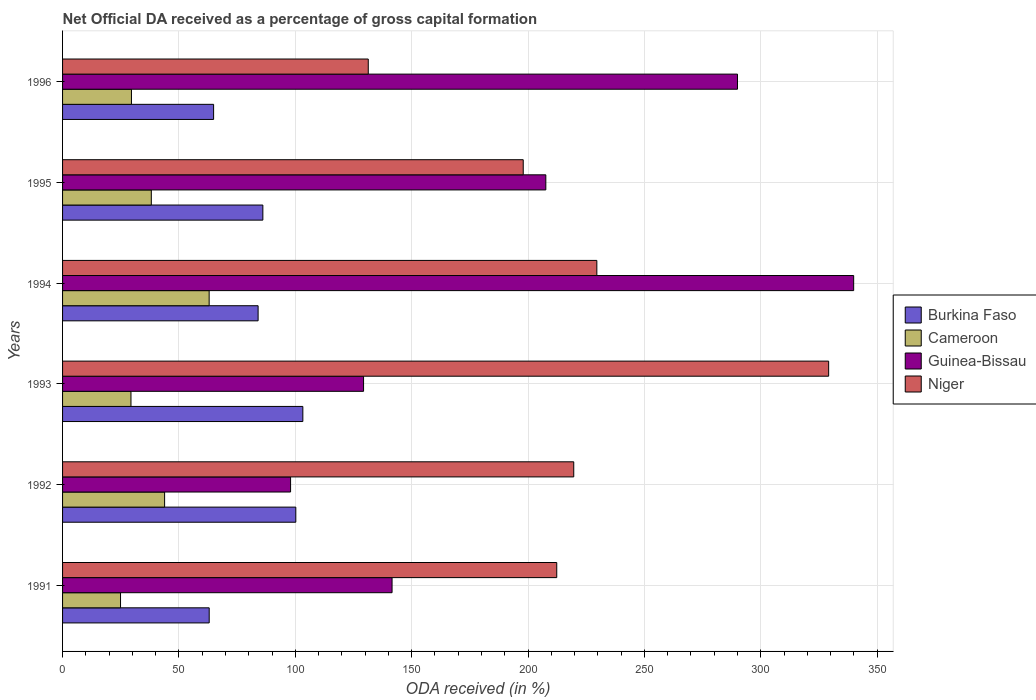How many different coloured bars are there?
Your answer should be compact. 4. How many groups of bars are there?
Ensure brevity in your answer.  6. Are the number of bars on each tick of the Y-axis equal?
Offer a terse response. Yes. How many bars are there on the 1st tick from the top?
Provide a short and direct response. 4. What is the label of the 1st group of bars from the top?
Offer a terse response. 1996. In how many cases, is the number of bars for a given year not equal to the number of legend labels?
Offer a very short reply. 0. What is the net ODA received in Niger in 1996?
Give a very brief answer. 131.35. Across all years, what is the maximum net ODA received in Niger?
Offer a very short reply. 329.16. Across all years, what is the minimum net ODA received in Guinea-Bissau?
Offer a terse response. 97.97. In which year was the net ODA received in Burkina Faso maximum?
Make the answer very short. 1993. What is the total net ODA received in Niger in the graph?
Provide a succinct answer. 1319.97. What is the difference between the net ODA received in Niger in 1993 and that in 1994?
Provide a short and direct response. 99.6. What is the difference between the net ODA received in Burkina Faso in 1991 and the net ODA received in Cameroon in 1995?
Make the answer very short. 24.87. What is the average net ODA received in Niger per year?
Your response must be concise. 220. In the year 1995, what is the difference between the net ODA received in Burkina Faso and net ODA received in Niger?
Provide a short and direct response. -111.87. In how many years, is the net ODA received in Guinea-Bissau greater than 130 %?
Provide a short and direct response. 4. What is the ratio of the net ODA received in Burkina Faso in 1992 to that in 1993?
Provide a short and direct response. 0.97. Is the net ODA received in Niger in 1993 less than that in 1996?
Provide a short and direct response. No. What is the difference between the highest and the second highest net ODA received in Cameroon?
Offer a terse response. 19.14. What is the difference between the highest and the lowest net ODA received in Guinea-Bissau?
Offer a very short reply. 241.94. In how many years, is the net ODA received in Niger greater than the average net ODA received in Niger taken over all years?
Provide a succinct answer. 2. What does the 4th bar from the top in 1996 represents?
Provide a succinct answer. Burkina Faso. What does the 4th bar from the bottom in 1992 represents?
Provide a succinct answer. Niger. How many bars are there?
Offer a very short reply. 24. Are all the bars in the graph horizontal?
Provide a short and direct response. Yes. How many years are there in the graph?
Give a very brief answer. 6. Does the graph contain any zero values?
Make the answer very short. No. Where does the legend appear in the graph?
Your response must be concise. Center right. How are the legend labels stacked?
Ensure brevity in your answer.  Vertical. What is the title of the graph?
Give a very brief answer. Net Official DA received as a percentage of gross capital formation. What is the label or title of the X-axis?
Your answer should be very brief. ODA received (in %). What is the label or title of the Y-axis?
Provide a succinct answer. Years. What is the ODA received (in %) in Burkina Faso in 1991?
Make the answer very short. 63. What is the ODA received (in %) of Cameroon in 1991?
Make the answer very short. 24.9. What is the ODA received (in %) of Guinea-Bissau in 1991?
Offer a very short reply. 141.57. What is the ODA received (in %) of Niger in 1991?
Offer a terse response. 212.33. What is the ODA received (in %) in Burkina Faso in 1992?
Provide a short and direct response. 100.22. What is the ODA received (in %) in Cameroon in 1992?
Offer a very short reply. 43.84. What is the ODA received (in %) in Guinea-Bissau in 1992?
Make the answer very short. 97.97. What is the ODA received (in %) in Niger in 1992?
Offer a very short reply. 219.64. What is the ODA received (in %) in Burkina Faso in 1993?
Ensure brevity in your answer.  103.24. What is the ODA received (in %) of Cameroon in 1993?
Make the answer very short. 29.39. What is the ODA received (in %) in Guinea-Bissau in 1993?
Provide a succinct answer. 129.32. What is the ODA received (in %) of Niger in 1993?
Make the answer very short. 329.16. What is the ODA received (in %) of Burkina Faso in 1994?
Your response must be concise. 84.02. What is the ODA received (in %) in Cameroon in 1994?
Your answer should be very brief. 62.99. What is the ODA received (in %) of Guinea-Bissau in 1994?
Your answer should be very brief. 339.91. What is the ODA received (in %) in Niger in 1994?
Your answer should be compact. 229.56. What is the ODA received (in %) of Burkina Faso in 1995?
Make the answer very short. 86.06. What is the ODA received (in %) in Cameroon in 1995?
Keep it short and to the point. 38.13. What is the ODA received (in %) of Guinea-Bissau in 1995?
Provide a short and direct response. 207.64. What is the ODA received (in %) in Niger in 1995?
Keep it short and to the point. 197.93. What is the ODA received (in %) of Burkina Faso in 1996?
Make the answer very short. 64.9. What is the ODA received (in %) in Cameroon in 1996?
Provide a short and direct response. 29.6. What is the ODA received (in %) of Guinea-Bissau in 1996?
Ensure brevity in your answer.  289.99. What is the ODA received (in %) of Niger in 1996?
Offer a very short reply. 131.35. Across all years, what is the maximum ODA received (in %) of Burkina Faso?
Keep it short and to the point. 103.24. Across all years, what is the maximum ODA received (in %) of Cameroon?
Make the answer very short. 62.99. Across all years, what is the maximum ODA received (in %) of Guinea-Bissau?
Offer a terse response. 339.91. Across all years, what is the maximum ODA received (in %) of Niger?
Offer a very short reply. 329.16. Across all years, what is the minimum ODA received (in %) of Burkina Faso?
Offer a terse response. 63. Across all years, what is the minimum ODA received (in %) of Cameroon?
Your answer should be compact. 24.9. Across all years, what is the minimum ODA received (in %) in Guinea-Bissau?
Keep it short and to the point. 97.97. Across all years, what is the minimum ODA received (in %) of Niger?
Make the answer very short. 131.35. What is the total ODA received (in %) in Burkina Faso in the graph?
Your answer should be compact. 501.44. What is the total ODA received (in %) in Cameroon in the graph?
Your answer should be very brief. 228.85. What is the total ODA received (in %) of Guinea-Bissau in the graph?
Offer a terse response. 1206.4. What is the total ODA received (in %) of Niger in the graph?
Give a very brief answer. 1319.97. What is the difference between the ODA received (in %) in Burkina Faso in 1991 and that in 1992?
Offer a terse response. -37.22. What is the difference between the ODA received (in %) in Cameroon in 1991 and that in 1992?
Give a very brief answer. -18.94. What is the difference between the ODA received (in %) in Guinea-Bissau in 1991 and that in 1992?
Offer a very short reply. 43.61. What is the difference between the ODA received (in %) in Niger in 1991 and that in 1992?
Provide a succinct answer. -7.31. What is the difference between the ODA received (in %) in Burkina Faso in 1991 and that in 1993?
Your answer should be compact. -40.23. What is the difference between the ODA received (in %) of Cameroon in 1991 and that in 1993?
Provide a succinct answer. -4.49. What is the difference between the ODA received (in %) in Guinea-Bissau in 1991 and that in 1993?
Ensure brevity in your answer.  12.25. What is the difference between the ODA received (in %) in Niger in 1991 and that in 1993?
Offer a terse response. -116.83. What is the difference between the ODA received (in %) of Burkina Faso in 1991 and that in 1994?
Offer a very short reply. -21.02. What is the difference between the ODA received (in %) of Cameroon in 1991 and that in 1994?
Give a very brief answer. -38.08. What is the difference between the ODA received (in %) of Guinea-Bissau in 1991 and that in 1994?
Your answer should be very brief. -198.33. What is the difference between the ODA received (in %) of Niger in 1991 and that in 1994?
Your answer should be very brief. -17.23. What is the difference between the ODA received (in %) of Burkina Faso in 1991 and that in 1995?
Your answer should be compact. -23.06. What is the difference between the ODA received (in %) of Cameroon in 1991 and that in 1995?
Provide a short and direct response. -13.23. What is the difference between the ODA received (in %) in Guinea-Bissau in 1991 and that in 1995?
Ensure brevity in your answer.  -66.06. What is the difference between the ODA received (in %) in Niger in 1991 and that in 1995?
Keep it short and to the point. 14.4. What is the difference between the ODA received (in %) of Burkina Faso in 1991 and that in 1996?
Your answer should be very brief. -1.9. What is the difference between the ODA received (in %) in Cameroon in 1991 and that in 1996?
Make the answer very short. -4.69. What is the difference between the ODA received (in %) of Guinea-Bissau in 1991 and that in 1996?
Your response must be concise. -148.41. What is the difference between the ODA received (in %) in Niger in 1991 and that in 1996?
Give a very brief answer. 80.98. What is the difference between the ODA received (in %) of Burkina Faso in 1992 and that in 1993?
Provide a succinct answer. -3.02. What is the difference between the ODA received (in %) in Cameroon in 1992 and that in 1993?
Your answer should be compact. 14.45. What is the difference between the ODA received (in %) of Guinea-Bissau in 1992 and that in 1993?
Ensure brevity in your answer.  -31.36. What is the difference between the ODA received (in %) in Niger in 1992 and that in 1993?
Give a very brief answer. -109.52. What is the difference between the ODA received (in %) in Burkina Faso in 1992 and that in 1994?
Your answer should be very brief. 16.2. What is the difference between the ODA received (in %) in Cameroon in 1992 and that in 1994?
Provide a short and direct response. -19.14. What is the difference between the ODA received (in %) of Guinea-Bissau in 1992 and that in 1994?
Provide a succinct answer. -241.94. What is the difference between the ODA received (in %) of Niger in 1992 and that in 1994?
Ensure brevity in your answer.  -9.92. What is the difference between the ODA received (in %) of Burkina Faso in 1992 and that in 1995?
Ensure brevity in your answer.  14.16. What is the difference between the ODA received (in %) in Cameroon in 1992 and that in 1995?
Make the answer very short. 5.71. What is the difference between the ODA received (in %) of Guinea-Bissau in 1992 and that in 1995?
Your response must be concise. -109.67. What is the difference between the ODA received (in %) of Niger in 1992 and that in 1995?
Give a very brief answer. 21.71. What is the difference between the ODA received (in %) in Burkina Faso in 1992 and that in 1996?
Your answer should be very brief. 35.32. What is the difference between the ODA received (in %) of Cameroon in 1992 and that in 1996?
Provide a succinct answer. 14.25. What is the difference between the ODA received (in %) in Guinea-Bissau in 1992 and that in 1996?
Give a very brief answer. -192.02. What is the difference between the ODA received (in %) in Niger in 1992 and that in 1996?
Offer a terse response. 88.29. What is the difference between the ODA received (in %) in Burkina Faso in 1993 and that in 1994?
Give a very brief answer. 19.22. What is the difference between the ODA received (in %) of Cameroon in 1993 and that in 1994?
Offer a terse response. -33.6. What is the difference between the ODA received (in %) of Guinea-Bissau in 1993 and that in 1994?
Your answer should be compact. -210.58. What is the difference between the ODA received (in %) of Niger in 1993 and that in 1994?
Make the answer very short. 99.6. What is the difference between the ODA received (in %) of Burkina Faso in 1993 and that in 1995?
Offer a terse response. 17.18. What is the difference between the ODA received (in %) of Cameroon in 1993 and that in 1995?
Offer a very short reply. -8.74. What is the difference between the ODA received (in %) in Guinea-Bissau in 1993 and that in 1995?
Offer a very short reply. -78.31. What is the difference between the ODA received (in %) of Niger in 1993 and that in 1995?
Offer a very short reply. 131.23. What is the difference between the ODA received (in %) in Burkina Faso in 1993 and that in 1996?
Ensure brevity in your answer.  38.34. What is the difference between the ODA received (in %) of Cameroon in 1993 and that in 1996?
Your answer should be very brief. -0.21. What is the difference between the ODA received (in %) in Guinea-Bissau in 1993 and that in 1996?
Keep it short and to the point. -160.66. What is the difference between the ODA received (in %) in Niger in 1993 and that in 1996?
Offer a terse response. 197.81. What is the difference between the ODA received (in %) of Burkina Faso in 1994 and that in 1995?
Provide a succinct answer. -2.04. What is the difference between the ODA received (in %) in Cameroon in 1994 and that in 1995?
Offer a very short reply. 24.85. What is the difference between the ODA received (in %) of Guinea-Bissau in 1994 and that in 1995?
Offer a terse response. 132.27. What is the difference between the ODA received (in %) in Niger in 1994 and that in 1995?
Provide a succinct answer. 31.63. What is the difference between the ODA received (in %) in Burkina Faso in 1994 and that in 1996?
Offer a terse response. 19.12. What is the difference between the ODA received (in %) in Cameroon in 1994 and that in 1996?
Offer a very short reply. 33.39. What is the difference between the ODA received (in %) in Guinea-Bissau in 1994 and that in 1996?
Provide a succinct answer. 49.92. What is the difference between the ODA received (in %) of Niger in 1994 and that in 1996?
Offer a terse response. 98.21. What is the difference between the ODA received (in %) of Burkina Faso in 1995 and that in 1996?
Ensure brevity in your answer.  21.16. What is the difference between the ODA received (in %) in Cameroon in 1995 and that in 1996?
Offer a very short reply. 8.54. What is the difference between the ODA received (in %) of Guinea-Bissau in 1995 and that in 1996?
Your answer should be compact. -82.35. What is the difference between the ODA received (in %) in Niger in 1995 and that in 1996?
Make the answer very short. 66.58. What is the difference between the ODA received (in %) of Burkina Faso in 1991 and the ODA received (in %) of Cameroon in 1992?
Ensure brevity in your answer.  19.16. What is the difference between the ODA received (in %) in Burkina Faso in 1991 and the ODA received (in %) in Guinea-Bissau in 1992?
Your answer should be compact. -34.96. What is the difference between the ODA received (in %) of Burkina Faso in 1991 and the ODA received (in %) of Niger in 1992?
Your answer should be very brief. -156.63. What is the difference between the ODA received (in %) in Cameroon in 1991 and the ODA received (in %) in Guinea-Bissau in 1992?
Offer a terse response. -73.06. What is the difference between the ODA received (in %) of Cameroon in 1991 and the ODA received (in %) of Niger in 1992?
Ensure brevity in your answer.  -194.74. What is the difference between the ODA received (in %) of Guinea-Bissau in 1991 and the ODA received (in %) of Niger in 1992?
Your response must be concise. -78.06. What is the difference between the ODA received (in %) of Burkina Faso in 1991 and the ODA received (in %) of Cameroon in 1993?
Your response must be concise. 33.61. What is the difference between the ODA received (in %) in Burkina Faso in 1991 and the ODA received (in %) in Guinea-Bissau in 1993?
Provide a short and direct response. -66.32. What is the difference between the ODA received (in %) in Burkina Faso in 1991 and the ODA received (in %) in Niger in 1993?
Your answer should be compact. -266.15. What is the difference between the ODA received (in %) of Cameroon in 1991 and the ODA received (in %) of Guinea-Bissau in 1993?
Give a very brief answer. -104.42. What is the difference between the ODA received (in %) in Cameroon in 1991 and the ODA received (in %) in Niger in 1993?
Your response must be concise. -304.26. What is the difference between the ODA received (in %) of Guinea-Bissau in 1991 and the ODA received (in %) of Niger in 1993?
Offer a very short reply. -187.58. What is the difference between the ODA received (in %) in Burkina Faso in 1991 and the ODA received (in %) in Cameroon in 1994?
Offer a very short reply. 0.02. What is the difference between the ODA received (in %) of Burkina Faso in 1991 and the ODA received (in %) of Guinea-Bissau in 1994?
Offer a terse response. -276.9. What is the difference between the ODA received (in %) in Burkina Faso in 1991 and the ODA received (in %) in Niger in 1994?
Give a very brief answer. -166.56. What is the difference between the ODA received (in %) in Cameroon in 1991 and the ODA received (in %) in Guinea-Bissau in 1994?
Make the answer very short. -315.01. What is the difference between the ODA received (in %) in Cameroon in 1991 and the ODA received (in %) in Niger in 1994?
Your answer should be compact. -204.66. What is the difference between the ODA received (in %) of Guinea-Bissau in 1991 and the ODA received (in %) of Niger in 1994?
Ensure brevity in your answer.  -87.99. What is the difference between the ODA received (in %) of Burkina Faso in 1991 and the ODA received (in %) of Cameroon in 1995?
Make the answer very short. 24.87. What is the difference between the ODA received (in %) of Burkina Faso in 1991 and the ODA received (in %) of Guinea-Bissau in 1995?
Make the answer very short. -144.63. What is the difference between the ODA received (in %) in Burkina Faso in 1991 and the ODA received (in %) in Niger in 1995?
Your answer should be compact. -134.93. What is the difference between the ODA received (in %) in Cameroon in 1991 and the ODA received (in %) in Guinea-Bissau in 1995?
Ensure brevity in your answer.  -182.73. What is the difference between the ODA received (in %) in Cameroon in 1991 and the ODA received (in %) in Niger in 1995?
Make the answer very short. -173.03. What is the difference between the ODA received (in %) in Guinea-Bissau in 1991 and the ODA received (in %) in Niger in 1995?
Provide a succinct answer. -56.36. What is the difference between the ODA received (in %) of Burkina Faso in 1991 and the ODA received (in %) of Cameroon in 1996?
Offer a terse response. 33.41. What is the difference between the ODA received (in %) in Burkina Faso in 1991 and the ODA received (in %) in Guinea-Bissau in 1996?
Ensure brevity in your answer.  -226.98. What is the difference between the ODA received (in %) in Burkina Faso in 1991 and the ODA received (in %) in Niger in 1996?
Give a very brief answer. -68.34. What is the difference between the ODA received (in %) in Cameroon in 1991 and the ODA received (in %) in Guinea-Bissau in 1996?
Offer a very short reply. -265.08. What is the difference between the ODA received (in %) in Cameroon in 1991 and the ODA received (in %) in Niger in 1996?
Your answer should be very brief. -106.45. What is the difference between the ODA received (in %) in Guinea-Bissau in 1991 and the ODA received (in %) in Niger in 1996?
Provide a short and direct response. 10.23. What is the difference between the ODA received (in %) of Burkina Faso in 1992 and the ODA received (in %) of Cameroon in 1993?
Offer a terse response. 70.83. What is the difference between the ODA received (in %) of Burkina Faso in 1992 and the ODA received (in %) of Guinea-Bissau in 1993?
Offer a very short reply. -29.1. What is the difference between the ODA received (in %) in Burkina Faso in 1992 and the ODA received (in %) in Niger in 1993?
Keep it short and to the point. -228.94. What is the difference between the ODA received (in %) in Cameroon in 1992 and the ODA received (in %) in Guinea-Bissau in 1993?
Your answer should be compact. -85.48. What is the difference between the ODA received (in %) in Cameroon in 1992 and the ODA received (in %) in Niger in 1993?
Give a very brief answer. -285.32. What is the difference between the ODA received (in %) in Guinea-Bissau in 1992 and the ODA received (in %) in Niger in 1993?
Keep it short and to the point. -231.19. What is the difference between the ODA received (in %) of Burkina Faso in 1992 and the ODA received (in %) of Cameroon in 1994?
Provide a succinct answer. 37.23. What is the difference between the ODA received (in %) in Burkina Faso in 1992 and the ODA received (in %) in Guinea-Bissau in 1994?
Offer a very short reply. -239.69. What is the difference between the ODA received (in %) of Burkina Faso in 1992 and the ODA received (in %) of Niger in 1994?
Offer a very short reply. -129.34. What is the difference between the ODA received (in %) in Cameroon in 1992 and the ODA received (in %) in Guinea-Bissau in 1994?
Offer a very short reply. -296.06. What is the difference between the ODA received (in %) in Cameroon in 1992 and the ODA received (in %) in Niger in 1994?
Provide a short and direct response. -185.72. What is the difference between the ODA received (in %) of Guinea-Bissau in 1992 and the ODA received (in %) of Niger in 1994?
Offer a terse response. -131.59. What is the difference between the ODA received (in %) of Burkina Faso in 1992 and the ODA received (in %) of Cameroon in 1995?
Your answer should be compact. 62.09. What is the difference between the ODA received (in %) of Burkina Faso in 1992 and the ODA received (in %) of Guinea-Bissau in 1995?
Your answer should be compact. -107.42. What is the difference between the ODA received (in %) in Burkina Faso in 1992 and the ODA received (in %) in Niger in 1995?
Keep it short and to the point. -97.71. What is the difference between the ODA received (in %) in Cameroon in 1992 and the ODA received (in %) in Guinea-Bissau in 1995?
Provide a short and direct response. -163.79. What is the difference between the ODA received (in %) of Cameroon in 1992 and the ODA received (in %) of Niger in 1995?
Your answer should be very brief. -154.09. What is the difference between the ODA received (in %) in Guinea-Bissau in 1992 and the ODA received (in %) in Niger in 1995?
Offer a terse response. -99.97. What is the difference between the ODA received (in %) in Burkina Faso in 1992 and the ODA received (in %) in Cameroon in 1996?
Give a very brief answer. 70.62. What is the difference between the ODA received (in %) of Burkina Faso in 1992 and the ODA received (in %) of Guinea-Bissau in 1996?
Offer a terse response. -189.77. What is the difference between the ODA received (in %) in Burkina Faso in 1992 and the ODA received (in %) in Niger in 1996?
Provide a short and direct response. -31.13. What is the difference between the ODA received (in %) of Cameroon in 1992 and the ODA received (in %) of Guinea-Bissau in 1996?
Your answer should be compact. -246.14. What is the difference between the ODA received (in %) in Cameroon in 1992 and the ODA received (in %) in Niger in 1996?
Your answer should be very brief. -87.5. What is the difference between the ODA received (in %) of Guinea-Bissau in 1992 and the ODA received (in %) of Niger in 1996?
Offer a terse response. -33.38. What is the difference between the ODA received (in %) of Burkina Faso in 1993 and the ODA received (in %) of Cameroon in 1994?
Ensure brevity in your answer.  40.25. What is the difference between the ODA received (in %) in Burkina Faso in 1993 and the ODA received (in %) in Guinea-Bissau in 1994?
Your response must be concise. -236.67. What is the difference between the ODA received (in %) of Burkina Faso in 1993 and the ODA received (in %) of Niger in 1994?
Provide a short and direct response. -126.32. What is the difference between the ODA received (in %) of Cameroon in 1993 and the ODA received (in %) of Guinea-Bissau in 1994?
Offer a terse response. -310.52. What is the difference between the ODA received (in %) of Cameroon in 1993 and the ODA received (in %) of Niger in 1994?
Ensure brevity in your answer.  -200.17. What is the difference between the ODA received (in %) of Guinea-Bissau in 1993 and the ODA received (in %) of Niger in 1994?
Your answer should be compact. -100.24. What is the difference between the ODA received (in %) of Burkina Faso in 1993 and the ODA received (in %) of Cameroon in 1995?
Your response must be concise. 65.11. What is the difference between the ODA received (in %) of Burkina Faso in 1993 and the ODA received (in %) of Guinea-Bissau in 1995?
Offer a very short reply. -104.4. What is the difference between the ODA received (in %) in Burkina Faso in 1993 and the ODA received (in %) in Niger in 1995?
Provide a short and direct response. -94.69. What is the difference between the ODA received (in %) of Cameroon in 1993 and the ODA received (in %) of Guinea-Bissau in 1995?
Your answer should be very brief. -178.25. What is the difference between the ODA received (in %) of Cameroon in 1993 and the ODA received (in %) of Niger in 1995?
Provide a short and direct response. -168.54. What is the difference between the ODA received (in %) of Guinea-Bissau in 1993 and the ODA received (in %) of Niger in 1995?
Make the answer very short. -68.61. What is the difference between the ODA received (in %) in Burkina Faso in 1993 and the ODA received (in %) in Cameroon in 1996?
Provide a short and direct response. 73.64. What is the difference between the ODA received (in %) in Burkina Faso in 1993 and the ODA received (in %) in Guinea-Bissau in 1996?
Provide a short and direct response. -186.75. What is the difference between the ODA received (in %) of Burkina Faso in 1993 and the ODA received (in %) of Niger in 1996?
Your answer should be compact. -28.11. What is the difference between the ODA received (in %) of Cameroon in 1993 and the ODA received (in %) of Guinea-Bissau in 1996?
Offer a terse response. -260.6. What is the difference between the ODA received (in %) of Cameroon in 1993 and the ODA received (in %) of Niger in 1996?
Make the answer very short. -101.96. What is the difference between the ODA received (in %) of Guinea-Bissau in 1993 and the ODA received (in %) of Niger in 1996?
Give a very brief answer. -2.02. What is the difference between the ODA received (in %) of Burkina Faso in 1994 and the ODA received (in %) of Cameroon in 1995?
Your response must be concise. 45.89. What is the difference between the ODA received (in %) of Burkina Faso in 1994 and the ODA received (in %) of Guinea-Bissau in 1995?
Offer a terse response. -123.62. What is the difference between the ODA received (in %) in Burkina Faso in 1994 and the ODA received (in %) in Niger in 1995?
Provide a short and direct response. -113.91. What is the difference between the ODA received (in %) of Cameroon in 1994 and the ODA received (in %) of Guinea-Bissau in 1995?
Ensure brevity in your answer.  -144.65. What is the difference between the ODA received (in %) of Cameroon in 1994 and the ODA received (in %) of Niger in 1995?
Give a very brief answer. -134.94. What is the difference between the ODA received (in %) in Guinea-Bissau in 1994 and the ODA received (in %) in Niger in 1995?
Give a very brief answer. 141.98. What is the difference between the ODA received (in %) in Burkina Faso in 1994 and the ODA received (in %) in Cameroon in 1996?
Your response must be concise. 54.42. What is the difference between the ODA received (in %) of Burkina Faso in 1994 and the ODA received (in %) of Guinea-Bissau in 1996?
Keep it short and to the point. -205.97. What is the difference between the ODA received (in %) of Burkina Faso in 1994 and the ODA received (in %) of Niger in 1996?
Keep it short and to the point. -47.33. What is the difference between the ODA received (in %) of Cameroon in 1994 and the ODA received (in %) of Guinea-Bissau in 1996?
Offer a very short reply. -227. What is the difference between the ODA received (in %) of Cameroon in 1994 and the ODA received (in %) of Niger in 1996?
Make the answer very short. -68.36. What is the difference between the ODA received (in %) in Guinea-Bissau in 1994 and the ODA received (in %) in Niger in 1996?
Offer a very short reply. 208.56. What is the difference between the ODA received (in %) of Burkina Faso in 1995 and the ODA received (in %) of Cameroon in 1996?
Your answer should be very brief. 56.46. What is the difference between the ODA received (in %) of Burkina Faso in 1995 and the ODA received (in %) of Guinea-Bissau in 1996?
Offer a very short reply. -203.93. What is the difference between the ODA received (in %) of Burkina Faso in 1995 and the ODA received (in %) of Niger in 1996?
Provide a short and direct response. -45.29. What is the difference between the ODA received (in %) in Cameroon in 1995 and the ODA received (in %) in Guinea-Bissau in 1996?
Your answer should be very brief. -251.85. What is the difference between the ODA received (in %) in Cameroon in 1995 and the ODA received (in %) in Niger in 1996?
Offer a very short reply. -93.22. What is the difference between the ODA received (in %) of Guinea-Bissau in 1995 and the ODA received (in %) of Niger in 1996?
Your response must be concise. 76.29. What is the average ODA received (in %) in Burkina Faso per year?
Offer a terse response. 83.57. What is the average ODA received (in %) in Cameroon per year?
Your answer should be very brief. 38.14. What is the average ODA received (in %) in Guinea-Bissau per year?
Your answer should be compact. 201.07. What is the average ODA received (in %) of Niger per year?
Your response must be concise. 220. In the year 1991, what is the difference between the ODA received (in %) in Burkina Faso and ODA received (in %) in Cameroon?
Your answer should be very brief. 38.1. In the year 1991, what is the difference between the ODA received (in %) in Burkina Faso and ODA received (in %) in Guinea-Bissau?
Offer a very short reply. -78.57. In the year 1991, what is the difference between the ODA received (in %) of Burkina Faso and ODA received (in %) of Niger?
Provide a short and direct response. -149.33. In the year 1991, what is the difference between the ODA received (in %) in Cameroon and ODA received (in %) in Guinea-Bissau?
Give a very brief answer. -116.67. In the year 1991, what is the difference between the ODA received (in %) in Cameroon and ODA received (in %) in Niger?
Your answer should be compact. -187.43. In the year 1991, what is the difference between the ODA received (in %) in Guinea-Bissau and ODA received (in %) in Niger?
Provide a short and direct response. -70.76. In the year 1992, what is the difference between the ODA received (in %) in Burkina Faso and ODA received (in %) in Cameroon?
Provide a succinct answer. 56.38. In the year 1992, what is the difference between the ODA received (in %) in Burkina Faso and ODA received (in %) in Guinea-Bissau?
Offer a terse response. 2.26. In the year 1992, what is the difference between the ODA received (in %) in Burkina Faso and ODA received (in %) in Niger?
Provide a succinct answer. -119.42. In the year 1992, what is the difference between the ODA received (in %) in Cameroon and ODA received (in %) in Guinea-Bissau?
Your response must be concise. -54.12. In the year 1992, what is the difference between the ODA received (in %) in Cameroon and ODA received (in %) in Niger?
Your response must be concise. -175.79. In the year 1992, what is the difference between the ODA received (in %) of Guinea-Bissau and ODA received (in %) of Niger?
Make the answer very short. -121.67. In the year 1993, what is the difference between the ODA received (in %) of Burkina Faso and ODA received (in %) of Cameroon?
Keep it short and to the point. 73.85. In the year 1993, what is the difference between the ODA received (in %) of Burkina Faso and ODA received (in %) of Guinea-Bissau?
Your response must be concise. -26.09. In the year 1993, what is the difference between the ODA received (in %) of Burkina Faso and ODA received (in %) of Niger?
Give a very brief answer. -225.92. In the year 1993, what is the difference between the ODA received (in %) of Cameroon and ODA received (in %) of Guinea-Bissau?
Your response must be concise. -99.93. In the year 1993, what is the difference between the ODA received (in %) in Cameroon and ODA received (in %) in Niger?
Your answer should be very brief. -299.77. In the year 1993, what is the difference between the ODA received (in %) of Guinea-Bissau and ODA received (in %) of Niger?
Keep it short and to the point. -199.84. In the year 1994, what is the difference between the ODA received (in %) of Burkina Faso and ODA received (in %) of Cameroon?
Offer a very short reply. 21.03. In the year 1994, what is the difference between the ODA received (in %) of Burkina Faso and ODA received (in %) of Guinea-Bissau?
Your answer should be compact. -255.89. In the year 1994, what is the difference between the ODA received (in %) in Burkina Faso and ODA received (in %) in Niger?
Give a very brief answer. -145.54. In the year 1994, what is the difference between the ODA received (in %) of Cameroon and ODA received (in %) of Guinea-Bissau?
Offer a terse response. -276.92. In the year 1994, what is the difference between the ODA received (in %) in Cameroon and ODA received (in %) in Niger?
Make the answer very short. -166.57. In the year 1994, what is the difference between the ODA received (in %) in Guinea-Bissau and ODA received (in %) in Niger?
Ensure brevity in your answer.  110.35. In the year 1995, what is the difference between the ODA received (in %) in Burkina Faso and ODA received (in %) in Cameroon?
Your response must be concise. 47.93. In the year 1995, what is the difference between the ODA received (in %) of Burkina Faso and ODA received (in %) of Guinea-Bissau?
Your answer should be very brief. -121.58. In the year 1995, what is the difference between the ODA received (in %) in Burkina Faso and ODA received (in %) in Niger?
Your answer should be compact. -111.87. In the year 1995, what is the difference between the ODA received (in %) in Cameroon and ODA received (in %) in Guinea-Bissau?
Give a very brief answer. -169.5. In the year 1995, what is the difference between the ODA received (in %) of Cameroon and ODA received (in %) of Niger?
Give a very brief answer. -159.8. In the year 1995, what is the difference between the ODA received (in %) in Guinea-Bissau and ODA received (in %) in Niger?
Your answer should be very brief. 9.71. In the year 1996, what is the difference between the ODA received (in %) in Burkina Faso and ODA received (in %) in Cameroon?
Keep it short and to the point. 35.3. In the year 1996, what is the difference between the ODA received (in %) in Burkina Faso and ODA received (in %) in Guinea-Bissau?
Provide a succinct answer. -225.09. In the year 1996, what is the difference between the ODA received (in %) in Burkina Faso and ODA received (in %) in Niger?
Keep it short and to the point. -66.45. In the year 1996, what is the difference between the ODA received (in %) of Cameroon and ODA received (in %) of Guinea-Bissau?
Provide a short and direct response. -260.39. In the year 1996, what is the difference between the ODA received (in %) of Cameroon and ODA received (in %) of Niger?
Keep it short and to the point. -101.75. In the year 1996, what is the difference between the ODA received (in %) in Guinea-Bissau and ODA received (in %) in Niger?
Provide a short and direct response. 158.64. What is the ratio of the ODA received (in %) of Burkina Faso in 1991 to that in 1992?
Make the answer very short. 0.63. What is the ratio of the ODA received (in %) of Cameroon in 1991 to that in 1992?
Your answer should be compact. 0.57. What is the ratio of the ODA received (in %) of Guinea-Bissau in 1991 to that in 1992?
Give a very brief answer. 1.45. What is the ratio of the ODA received (in %) of Niger in 1991 to that in 1992?
Your answer should be compact. 0.97. What is the ratio of the ODA received (in %) in Burkina Faso in 1991 to that in 1993?
Offer a terse response. 0.61. What is the ratio of the ODA received (in %) in Cameroon in 1991 to that in 1993?
Offer a terse response. 0.85. What is the ratio of the ODA received (in %) in Guinea-Bissau in 1991 to that in 1993?
Give a very brief answer. 1.09. What is the ratio of the ODA received (in %) in Niger in 1991 to that in 1993?
Provide a succinct answer. 0.65. What is the ratio of the ODA received (in %) in Burkina Faso in 1991 to that in 1994?
Provide a short and direct response. 0.75. What is the ratio of the ODA received (in %) of Cameroon in 1991 to that in 1994?
Give a very brief answer. 0.4. What is the ratio of the ODA received (in %) in Guinea-Bissau in 1991 to that in 1994?
Offer a terse response. 0.42. What is the ratio of the ODA received (in %) of Niger in 1991 to that in 1994?
Give a very brief answer. 0.93. What is the ratio of the ODA received (in %) in Burkina Faso in 1991 to that in 1995?
Ensure brevity in your answer.  0.73. What is the ratio of the ODA received (in %) in Cameroon in 1991 to that in 1995?
Give a very brief answer. 0.65. What is the ratio of the ODA received (in %) of Guinea-Bissau in 1991 to that in 1995?
Offer a very short reply. 0.68. What is the ratio of the ODA received (in %) in Niger in 1991 to that in 1995?
Offer a very short reply. 1.07. What is the ratio of the ODA received (in %) of Burkina Faso in 1991 to that in 1996?
Your response must be concise. 0.97. What is the ratio of the ODA received (in %) in Cameroon in 1991 to that in 1996?
Provide a succinct answer. 0.84. What is the ratio of the ODA received (in %) of Guinea-Bissau in 1991 to that in 1996?
Keep it short and to the point. 0.49. What is the ratio of the ODA received (in %) of Niger in 1991 to that in 1996?
Provide a succinct answer. 1.62. What is the ratio of the ODA received (in %) in Burkina Faso in 1992 to that in 1993?
Provide a succinct answer. 0.97. What is the ratio of the ODA received (in %) of Cameroon in 1992 to that in 1993?
Offer a very short reply. 1.49. What is the ratio of the ODA received (in %) in Guinea-Bissau in 1992 to that in 1993?
Ensure brevity in your answer.  0.76. What is the ratio of the ODA received (in %) of Niger in 1992 to that in 1993?
Offer a very short reply. 0.67. What is the ratio of the ODA received (in %) in Burkina Faso in 1992 to that in 1994?
Ensure brevity in your answer.  1.19. What is the ratio of the ODA received (in %) in Cameroon in 1992 to that in 1994?
Ensure brevity in your answer.  0.7. What is the ratio of the ODA received (in %) of Guinea-Bissau in 1992 to that in 1994?
Keep it short and to the point. 0.29. What is the ratio of the ODA received (in %) of Niger in 1992 to that in 1994?
Your answer should be compact. 0.96. What is the ratio of the ODA received (in %) in Burkina Faso in 1992 to that in 1995?
Offer a very short reply. 1.16. What is the ratio of the ODA received (in %) of Cameroon in 1992 to that in 1995?
Offer a terse response. 1.15. What is the ratio of the ODA received (in %) in Guinea-Bissau in 1992 to that in 1995?
Your answer should be very brief. 0.47. What is the ratio of the ODA received (in %) in Niger in 1992 to that in 1995?
Ensure brevity in your answer.  1.11. What is the ratio of the ODA received (in %) of Burkina Faso in 1992 to that in 1996?
Your response must be concise. 1.54. What is the ratio of the ODA received (in %) of Cameroon in 1992 to that in 1996?
Your answer should be very brief. 1.48. What is the ratio of the ODA received (in %) of Guinea-Bissau in 1992 to that in 1996?
Your answer should be compact. 0.34. What is the ratio of the ODA received (in %) of Niger in 1992 to that in 1996?
Offer a very short reply. 1.67. What is the ratio of the ODA received (in %) of Burkina Faso in 1993 to that in 1994?
Offer a very short reply. 1.23. What is the ratio of the ODA received (in %) in Cameroon in 1993 to that in 1994?
Offer a terse response. 0.47. What is the ratio of the ODA received (in %) in Guinea-Bissau in 1993 to that in 1994?
Offer a very short reply. 0.38. What is the ratio of the ODA received (in %) of Niger in 1993 to that in 1994?
Your answer should be very brief. 1.43. What is the ratio of the ODA received (in %) of Burkina Faso in 1993 to that in 1995?
Make the answer very short. 1.2. What is the ratio of the ODA received (in %) in Cameroon in 1993 to that in 1995?
Offer a terse response. 0.77. What is the ratio of the ODA received (in %) in Guinea-Bissau in 1993 to that in 1995?
Provide a succinct answer. 0.62. What is the ratio of the ODA received (in %) in Niger in 1993 to that in 1995?
Keep it short and to the point. 1.66. What is the ratio of the ODA received (in %) of Burkina Faso in 1993 to that in 1996?
Your answer should be very brief. 1.59. What is the ratio of the ODA received (in %) of Cameroon in 1993 to that in 1996?
Provide a succinct answer. 0.99. What is the ratio of the ODA received (in %) in Guinea-Bissau in 1993 to that in 1996?
Your response must be concise. 0.45. What is the ratio of the ODA received (in %) of Niger in 1993 to that in 1996?
Your response must be concise. 2.51. What is the ratio of the ODA received (in %) in Burkina Faso in 1994 to that in 1995?
Offer a terse response. 0.98. What is the ratio of the ODA received (in %) of Cameroon in 1994 to that in 1995?
Provide a succinct answer. 1.65. What is the ratio of the ODA received (in %) of Guinea-Bissau in 1994 to that in 1995?
Make the answer very short. 1.64. What is the ratio of the ODA received (in %) of Niger in 1994 to that in 1995?
Provide a short and direct response. 1.16. What is the ratio of the ODA received (in %) of Burkina Faso in 1994 to that in 1996?
Your answer should be very brief. 1.29. What is the ratio of the ODA received (in %) of Cameroon in 1994 to that in 1996?
Offer a very short reply. 2.13. What is the ratio of the ODA received (in %) of Guinea-Bissau in 1994 to that in 1996?
Provide a succinct answer. 1.17. What is the ratio of the ODA received (in %) in Niger in 1994 to that in 1996?
Make the answer very short. 1.75. What is the ratio of the ODA received (in %) in Burkina Faso in 1995 to that in 1996?
Make the answer very short. 1.33. What is the ratio of the ODA received (in %) in Cameroon in 1995 to that in 1996?
Provide a succinct answer. 1.29. What is the ratio of the ODA received (in %) of Guinea-Bissau in 1995 to that in 1996?
Keep it short and to the point. 0.72. What is the ratio of the ODA received (in %) of Niger in 1995 to that in 1996?
Your answer should be compact. 1.51. What is the difference between the highest and the second highest ODA received (in %) in Burkina Faso?
Ensure brevity in your answer.  3.02. What is the difference between the highest and the second highest ODA received (in %) in Cameroon?
Offer a terse response. 19.14. What is the difference between the highest and the second highest ODA received (in %) of Guinea-Bissau?
Make the answer very short. 49.92. What is the difference between the highest and the second highest ODA received (in %) of Niger?
Your answer should be compact. 99.6. What is the difference between the highest and the lowest ODA received (in %) of Burkina Faso?
Provide a succinct answer. 40.23. What is the difference between the highest and the lowest ODA received (in %) in Cameroon?
Keep it short and to the point. 38.08. What is the difference between the highest and the lowest ODA received (in %) in Guinea-Bissau?
Offer a very short reply. 241.94. What is the difference between the highest and the lowest ODA received (in %) in Niger?
Make the answer very short. 197.81. 